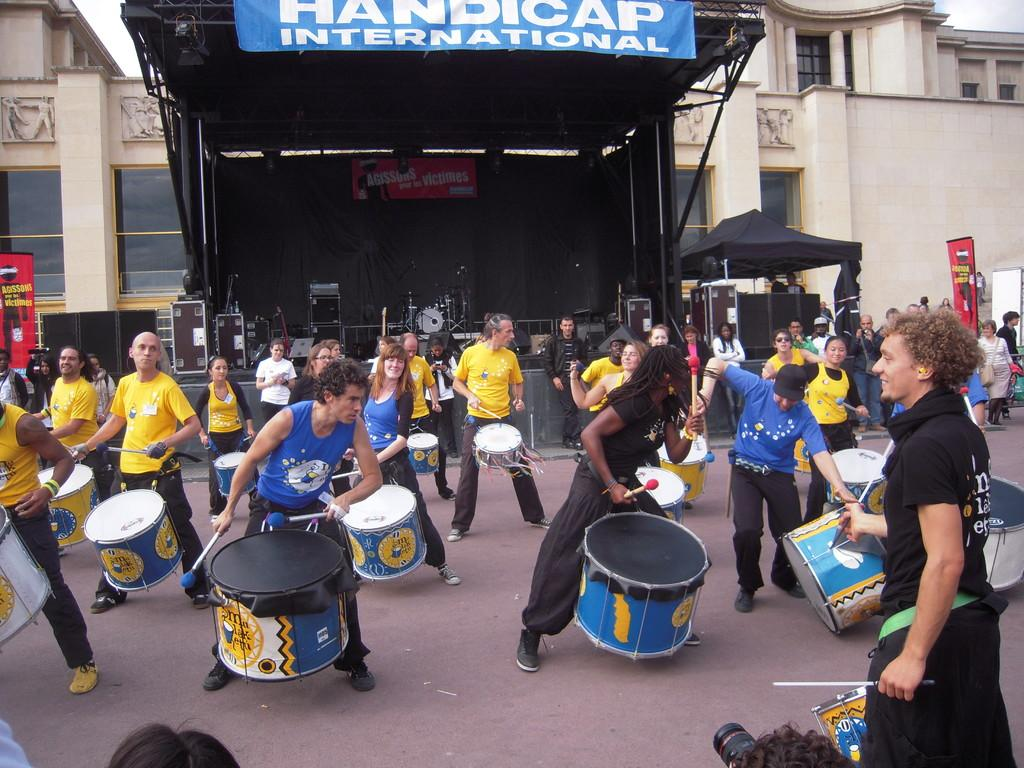What activity are the people in the image engaged in? The people in the image are playing drums. Are there any other people present in the image besides the drum players? Yes, there are people standing behind the drum players. What can be seen in the background of the image? There is a building in the background of the image. What type of advice is the governor giving to the person in the image? There is no governor or person present in the image; it features a group of people playing drums and people standing behind them. Can you see any ghosts interacting with the drum players in the image? There are no ghosts present in the image; it only shows people playing drums and standing behind them. 